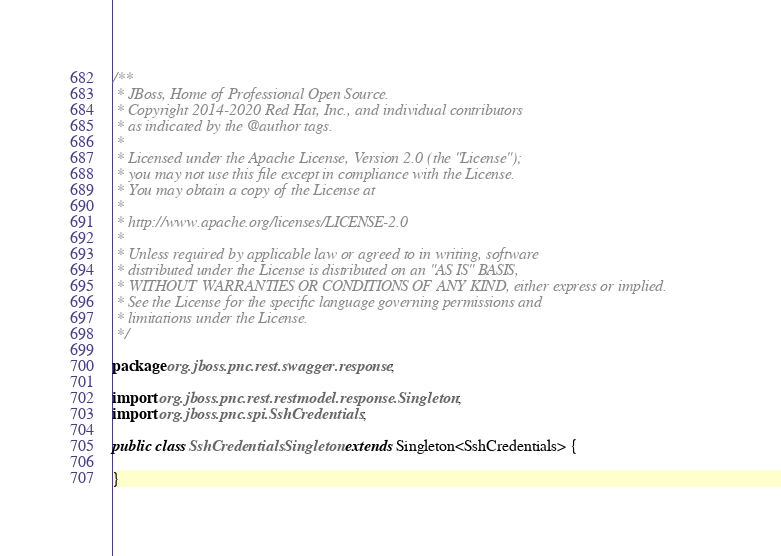<code> <loc_0><loc_0><loc_500><loc_500><_Java_>/**
 * JBoss, Home of Professional Open Source.
 * Copyright 2014-2020 Red Hat, Inc., and individual contributors
 * as indicated by the @author tags.
 *
 * Licensed under the Apache License, Version 2.0 (the "License");
 * you may not use this file except in compliance with the License.
 * You may obtain a copy of the License at
 *
 * http://www.apache.org/licenses/LICENSE-2.0
 *
 * Unless required by applicable law or agreed to in writing, software
 * distributed under the License is distributed on an "AS IS" BASIS,
 * WITHOUT WARRANTIES OR CONDITIONS OF ANY KIND, either express or implied.
 * See the License for the specific language governing permissions and
 * limitations under the License.
 */

package org.jboss.pnc.rest.swagger.response;

import org.jboss.pnc.rest.restmodel.response.Singleton;
import org.jboss.pnc.spi.SshCredentials;

public class SshCredentialsSingleton extends Singleton<SshCredentials> {

}
</code> 